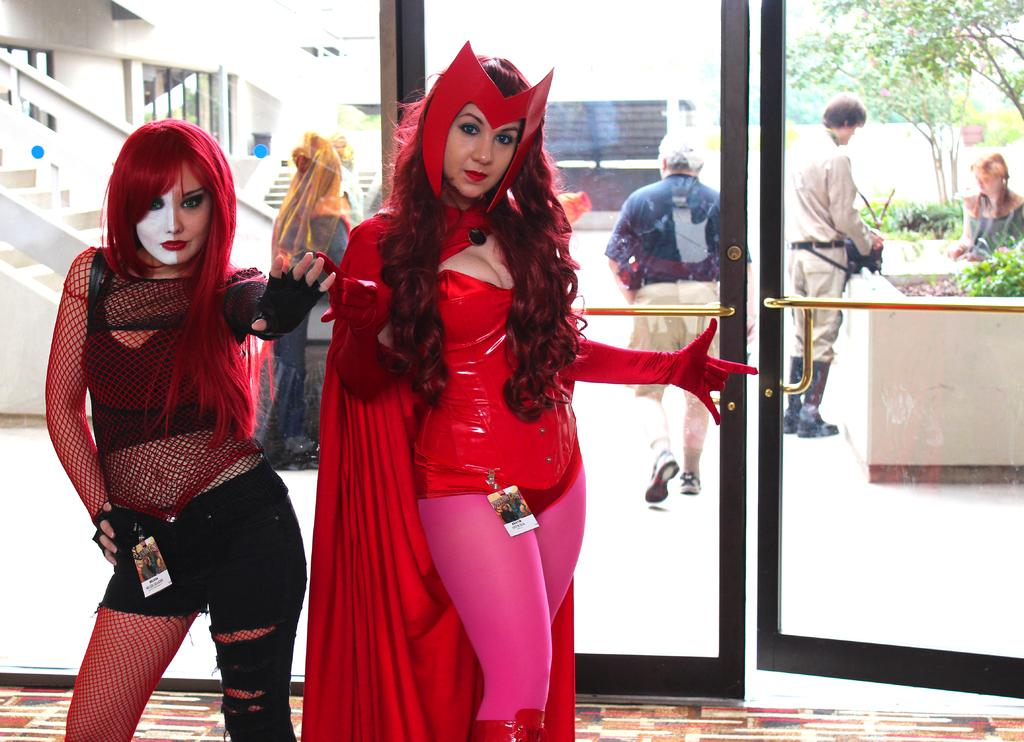What type of structures can be seen in the image? There are doors, people, stairs, buildings, plants, and trees visible in the image. Can you describe the architectural features in the image? The image features doors, stairs, and buildings. What type of vegetation is present in the image? There are plants and trees in the image. What type of fang can be seen in the image? There is no fang present in the image. What flavor of ice cream are the people eating in the image? There is no ice cream present in the image, so it is not possible to determine the flavor. 